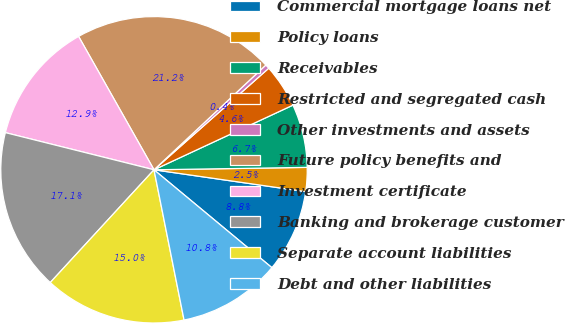Convert chart. <chart><loc_0><loc_0><loc_500><loc_500><pie_chart><fcel>Commercial mortgage loans net<fcel>Policy loans<fcel>Receivables<fcel>Restricted and segregated cash<fcel>Other investments and assets<fcel>Future policy benefits and<fcel>Investment certificate<fcel>Banking and brokerage customer<fcel>Separate account liabilities<fcel>Debt and other liabilities<nl><fcel>8.75%<fcel>2.53%<fcel>6.68%<fcel>4.6%<fcel>0.45%<fcel>21.21%<fcel>12.91%<fcel>17.06%<fcel>14.98%<fcel>10.83%<nl></chart> 